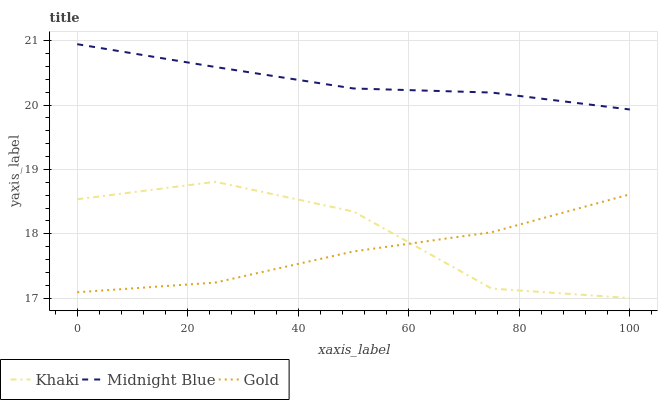Does Gold have the minimum area under the curve?
Answer yes or no. Yes. Does Midnight Blue have the maximum area under the curve?
Answer yes or no. Yes. Does Midnight Blue have the minimum area under the curve?
Answer yes or no. No. Does Gold have the maximum area under the curve?
Answer yes or no. No. Is Midnight Blue the smoothest?
Answer yes or no. Yes. Is Khaki the roughest?
Answer yes or no. Yes. Is Gold the smoothest?
Answer yes or no. No. Is Gold the roughest?
Answer yes or no. No. Does Khaki have the lowest value?
Answer yes or no. Yes. Does Gold have the lowest value?
Answer yes or no. No. Does Midnight Blue have the highest value?
Answer yes or no. Yes. Does Gold have the highest value?
Answer yes or no. No. Is Khaki less than Midnight Blue?
Answer yes or no. Yes. Is Midnight Blue greater than Gold?
Answer yes or no. Yes. Does Khaki intersect Gold?
Answer yes or no. Yes. Is Khaki less than Gold?
Answer yes or no. No. Is Khaki greater than Gold?
Answer yes or no. No. Does Khaki intersect Midnight Blue?
Answer yes or no. No. 